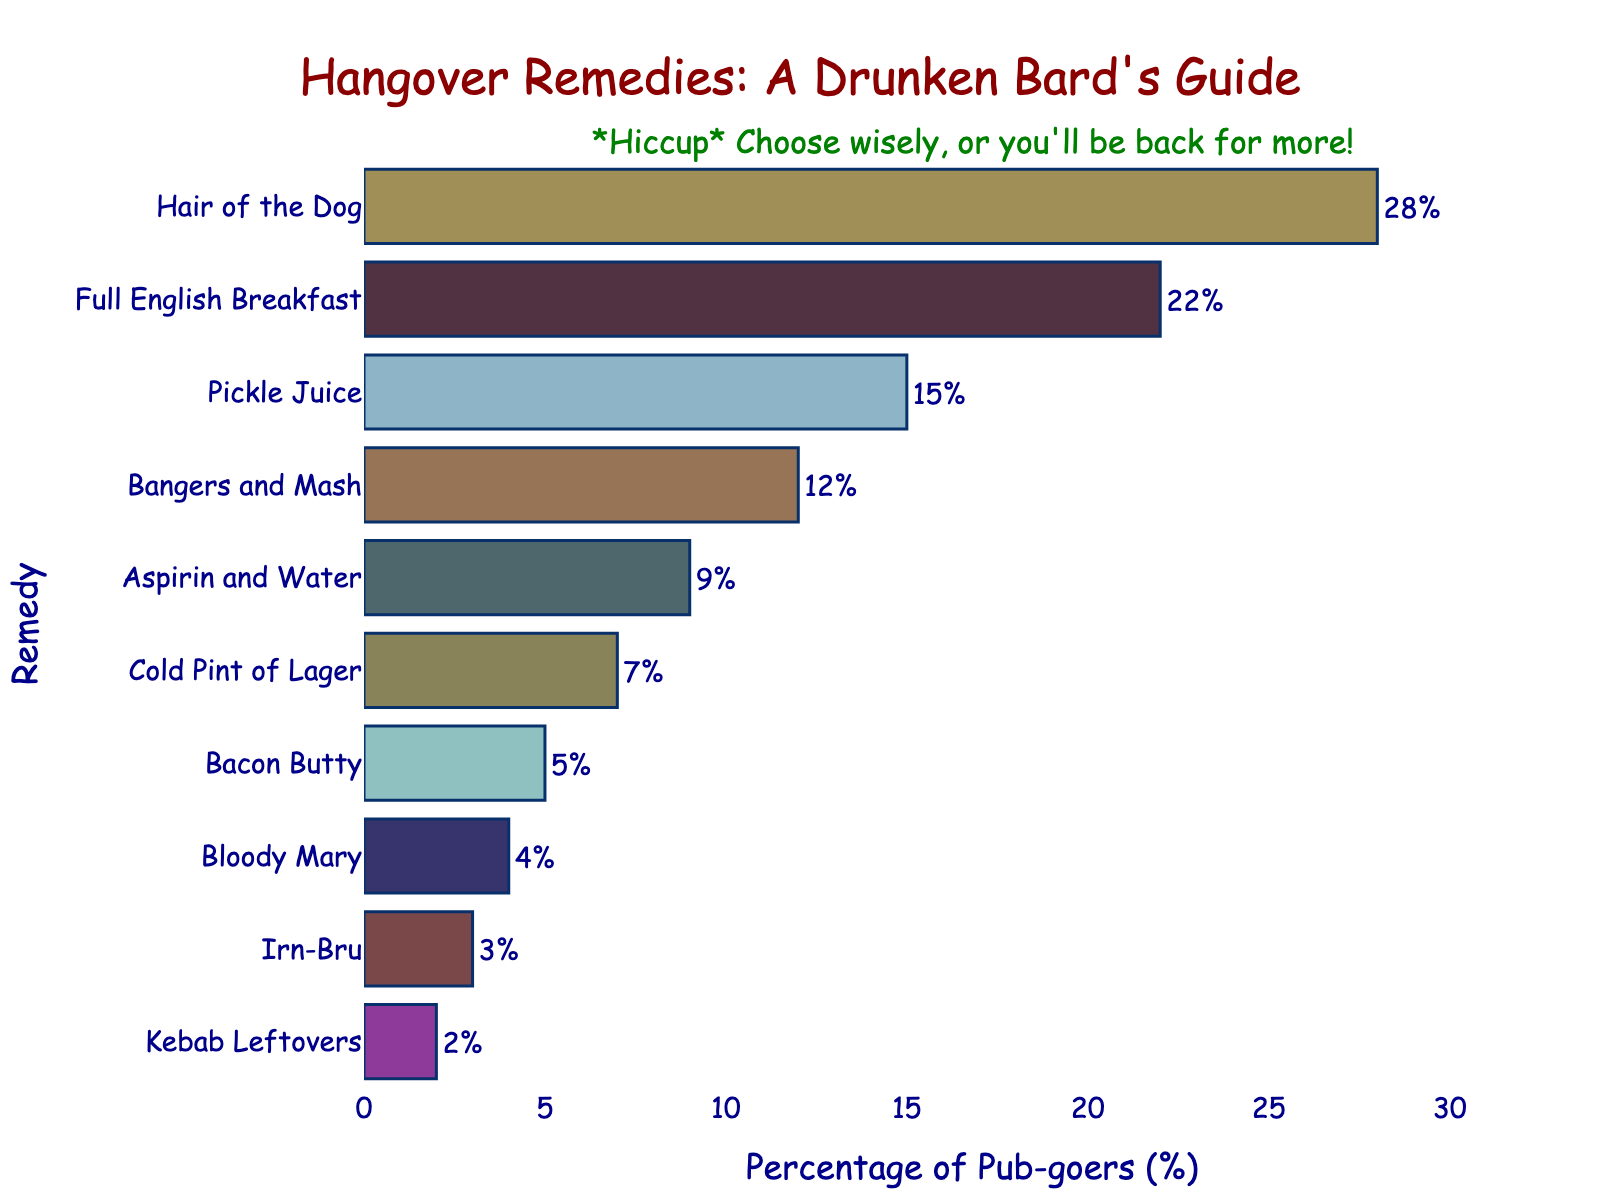Which hangover remedy is the most popular? The most popular remedy can be identified by looking at the bar with the highest percentage. The longest bar indicates "Hair of the Dog" at 28%.
Answer: Hair of the Dog Which remedy is preferred by the smallest percentage of pub-goers? The remedy with the smallest percentage can be found by locating the shortest bar. The shortest bar corresponds to "Kebab Leftovers" at 2%.
Answer: Kebab Leftovers What is the total percentage of pub-goers that prefer either "Pickle Juice" or "Bangers and Mash"? To find the total, add the percentages of "Pickle Juice" and "Bangers and Mash". 15% + 12% = 27%.
Answer: 27% How much more popular is "Hair of the Dog" compared to "Full English Breakfast"? Subtract the percentage of "Full English Breakfast" from "Hair of the Dog". 28% - 22% = 6%.
Answer: 6% Which remedies have a preference percentage greater than 20%? The remedies whose bars are longer than the 20% mark are "Hair of the Dog" and "Full English Breakfast" with 28% and 22%, respectively.
Answer: Hair of the Dog, Full English Breakfast Are there more people who prefer "Aspirin and Water" or a "Cold Pint of Lager"? Compare the lengths of the bars for "Aspirin and Water" (9%) and "Cold Pint of Lager" (7%). "Aspirin and Water" is preferred by more people.
Answer: Aspirin and Water What is the combined percentage for remedies with less than 5% preference? Sum the percentages for "Irn-Bru" (3%) and "Kebab Leftovers" (2%). 3% + 2% = 5%.
Answer: 5% Which remedy is just above "Cold Pint of Lager" in terms of preference percentage? Locate the bar just above "Cold Pint of Lager" (7%) which is "Aspirin and Water" at 9%.
Answer: Aspirin and Water What is the range between the highest and lowest percentage hangover remedies? Subtract the lowest percentage (2% for "Kebab Leftovers") from the highest percentage (28% for "Hair of the Dog"). 28% - 2% = 26%.
Answer: 26% How does the percentage of people who prefer "Bloody Mary" compare to those who prefer "Bacon Butty"? Compare the percentages of "Bloody Mary" (4%) and "Bacon Butty" (5%). "Bacon Butty" is preferred by a slightly higher percentage.
Answer: Bacon Butty 